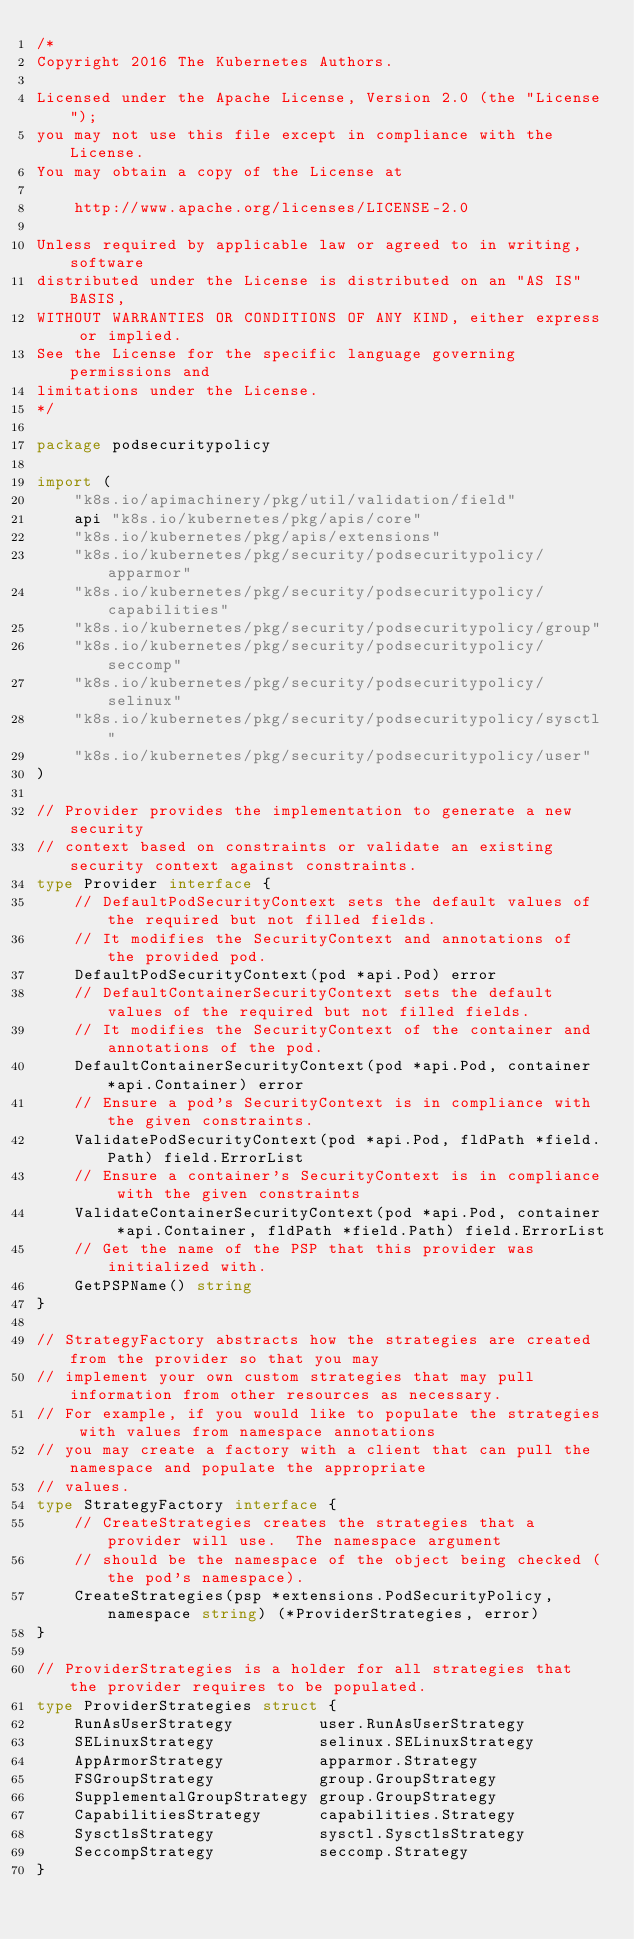Convert code to text. <code><loc_0><loc_0><loc_500><loc_500><_Go_>/*
Copyright 2016 The Kubernetes Authors.

Licensed under the Apache License, Version 2.0 (the "License");
you may not use this file except in compliance with the License.
You may obtain a copy of the License at

    http://www.apache.org/licenses/LICENSE-2.0

Unless required by applicable law or agreed to in writing, software
distributed under the License is distributed on an "AS IS" BASIS,
WITHOUT WARRANTIES OR CONDITIONS OF ANY KIND, either express or implied.
See the License for the specific language governing permissions and
limitations under the License.
*/

package podsecuritypolicy

import (
	"k8s.io/apimachinery/pkg/util/validation/field"
	api "k8s.io/kubernetes/pkg/apis/core"
	"k8s.io/kubernetes/pkg/apis/extensions"
	"k8s.io/kubernetes/pkg/security/podsecuritypolicy/apparmor"
	"k8s.io/kubernetes/pkg/security/podsecuritypolicy/capabilities"
	"k8s.io/kubernetes/pkg/security/podsecuritypolicy/group"
	"k8s.io/kubernetes/pkg/security/podsecuritypolicy/seccomp"
	"k8s.io/kubernetes/pkg/security/podsecuritypolicy/selinux"
	"k8s.io/kubernetes/pkg/security/podsecuritypolicy/sysctl"
	"k8s.io/kubernetes/pkg/security/podsecuritypolicy/user"
)

// Provider provides the implementation to generate a new security
// context based on constraints or validate an existing security context against constraints.
type Provider interface {
	// DefaultPodSecurityContext sets the default values of the required but not filled fields.
	// It modifies the SecurityContext and annotations of the provided pod.
	DefaultPodSecurityContext(pod *api.Pod) error
	// DefaultContainerSecurityContext sets the default values of the required but not filled fields.
	// It modifies the SecurityContext of the container and annotations of the pod.
	DefaultContainerSecurityContext(pod *api.Pod, container *api.Container) error
	// Ensure a pod's SecurityContext is in compliance with the given constraints.
	ValidatePodSecurityContext(pod *api.Pod, fldPath *field.Path) field.ErrorList
	// Ensure a container's SecurityContext is in compliance with the given constraints
	ValidateContainerSecurityContext(pod *api.Pod, container *api.Container, fldPath *field.Path) field.ErrorList
	// Get the name of the PSP that this provider was initialized with.
	GetPSPName() string
}

// StrategyFactory abstracts how the strategies are created from the provider so that you may
// implement your own custom strategies that may pull information from other resources as necessary.
// For example, if you would like to populate the strategies with values from namespace annotations
// you may create a factory with a client that can pull the namespace and populate the appropriate
// values.
type StrategyFactory interface {
	// CreateStrategies creates the strategies that a provider will use.  The namespace argument
	// should be the namespace of the object being checked (the pod's namespace).
	CreateStrategies(psp *extensions.PodSecurityPolicy, namespace string) (*ProviderStrategies, error)
}

// ProviderStrategies is a holder for all strategies that the provider requires to be populated.
type ProviderStrategies struct {
	RunAsUserStrategy         user.RunAsUserStrategy
	SELinuxStrategy           selinux.SELinuxStrategy
	AppArmorStrategy          apparmor.Strategy
	FSGroupStrategy           group.GroupStrategy
	SupplementalGroupStrategy group.GroupStrategy
	CapabilitiesStrategy      capabilities.Strategy
	SysctlsStrategy           sysctl.SysctlsStrategy
	SeccompStrategy           seccomp.Strategy
}
</code> 